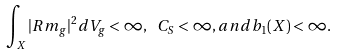Convert formula to latex. <formula><loc_0><loc_0><loc_500><loc_500>\int _ { X } | R m _ { g } | ^ { 2 } d V _ { g } < \infty , \ C _ { S } < \infty , a n d b _ { 1 } ( X ) < \infty .</formula> 